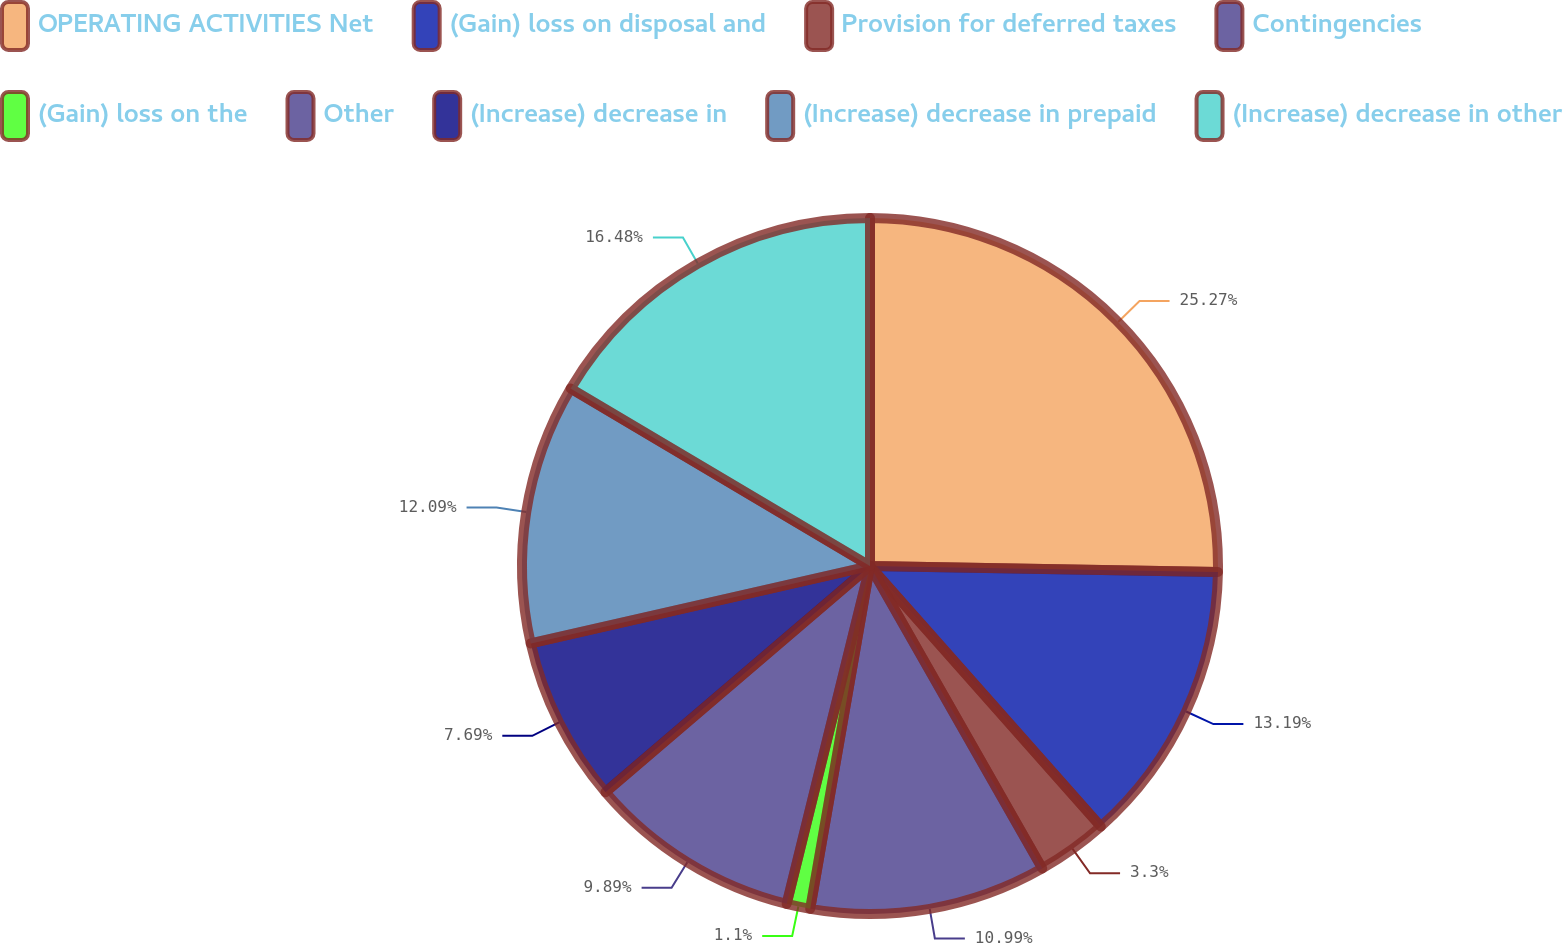Convert chart to OTSL. <chart><loc_0><loc_0><loc_500><loc_500><pie_chart><fcel>OPERATING ACTIVITIES Net<fcel>(Gain) loss on disposal and<fcel>Provision for deferred taxes<fcel>Contingencies<fcel>(Gain) loss on the<fcel>Other<fcel>(Increase) decrease in<fcel>(Increase) decrease in prepaid<fcel>(Increase) decrease in other<nl><fcel>25.27%<fcel>13.19%<fcel>3.3%<fcel>10.99%<fcel>1.1%<fcel>9.89%<fcel>7.69%<fcel>12.09%<fcel>16.48%<nl></chart> 